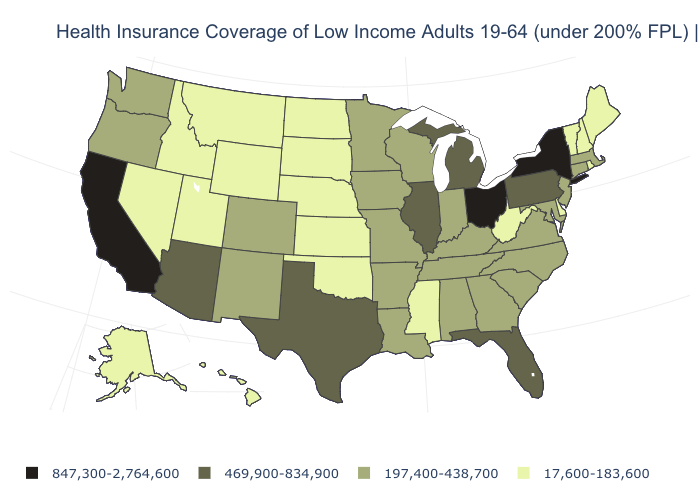Which states have the lowest value in the USA?
Keep it brief. Alaska, Delaware, Hawaii, Idaho, Kansas, Maine, Mississippi, Montana, Nebraska, Nevada, New Hampshire, North Dakota, Oklahoma, Rhode Island, South Dakota, Utah, Vermont, West Virginia, Wyoming. What is the value of Hawaii?
Concise answer only. 17,600-183,600. Does the map have missing data?
Write a very short answer. No. How many symbols are there in the legend?
Be succinct. 4. Does the map have missing data?
Give a very brief answer. No. What is the value of Florida?
Answer briefly. 469,900-834,900. What is the highest value in states that border Georgia?
Short answer required. 469,900-834,900. What is the lowest value in the Northeast?
Quick response, please. 17,600-183,600. How many symbols are there in the legend?
Concise answer only. 4. Does South Carolina have the lowest value in the USA?
Write a very short answer. No. Does North Carolina have the highest value in the USA?
Give a very brief answer. No. Does the first symbol in the legend represent the smallest category?
Keep it brief. No. What is the value of Wisconsin?
Quick response, please. 197,400-438,700. What is the value of Texas?
Keep it brief. 469,900-834,900. 